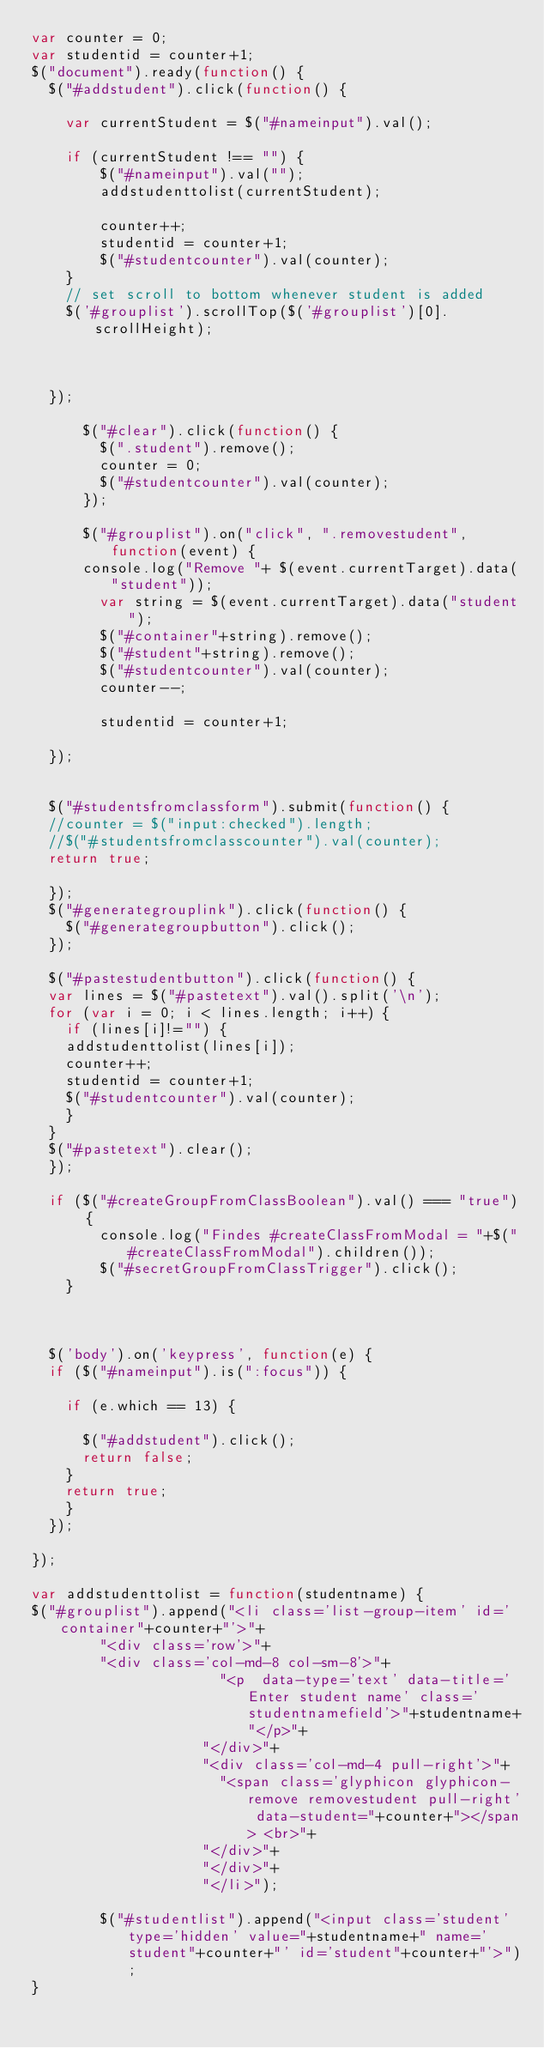Convert code to text. <code><loc_0><loc_0><loc_500><loc_500><_JavaScript_>var counter = 0;
var studentid = counter+1;
$("document").ready(function() {
  $("#addstudent").click(function() {

    var currentStudent = $("#nameinput").val();

    if (currentStudent !== "") {
        $("#nameinput").val("");
        addstudenttolist(currentStudent);

        counter++;
        studentid = counter+1;
        $("#studentcounter").val(counter);
    }
    // set scroll to bottom whenever student is added
    $('#grouplist').scrollTop($('#grouplist')[0].scrollHeight);



  });

      $("#clear").click(function() {
        $(".student").remove();
        counter = 0;
        $("#studentcounter").val(counter);
      });

      $("#grouplist").on("click", ".removestudent", function(event) {
      console.log("Remove "+ $(event.currentTarget).data("student"));
        var string = $(event.currentTarget).data("student");
        $("#container"+string).remove();
        $("#student"+string).remove();
        $("#studentcounter").val(counter);
        counter--;

        studentid = counter+1;

  });


  $("#studentsfromclassform").submit(function() {
  //counter = $("input:checked").length;
  //$("#studentsfromclasscounter").val(counter);
  return true;

  });
  $("#generategrouplink").click(function() {
    $("#generategroupbutton").click();
  });

  $("#pastestudentbutton").click(function() {
  var lines = $("#pastetext").val().split('\n');
  for (var i = 0; i < lines.length; i++) {
    if (lines[i]!="") {
    addstudenttolist(lines[i]);
    counter++;
    studentid = counter+1;
    $("#studentcounter").val(counter);
    }
  }
  $("#pastetext").clear();
  });

  if ($("#createGroupFromClassBoolean").val() === "true") {
        console.log("Findes #createClassFromModal = "+$("#createClassFromModal").children());
        $("#secretGroupFromClassTrigger").click();
    }



  $('body').on('keypress', function(e) {
  if ($("#nameinput").is(":focus")) {

    if (e.which == 13) {

      $("#addstudent").click();
      return false;
    }
    return true;
    }
  });

});

var addstudenttolist = function(studentname) {
$("#grouplist").append("<li class='list-group-item' id='container"+counter+"'>"+
        "<div class='row'>"+
        "<div class='col-md-8 col-sm-8'>"+
                      "<p  data-type='text' data-title='Enter student name' class='studentnamefield'>"+studentname+"</p>"+
                    "</div>"+
                    "<div class='col-md-4 pull-right'>"+
                      "<span class='glyphicon glyphicon-remove removestudent pull-right' data-student="+counter+"></span> <br>"+
                    "</div>"+
                    "</div>"+
                    "</li>");

        $("#studentlist").append("<input class='student' type='hidden' value="+studentname+" name='student"+counter+"' id='student"+counter+"'>");
}
</code> 